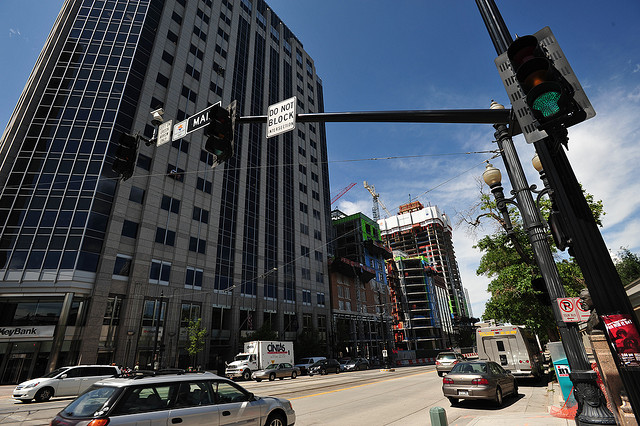<image>What do the hand sign and the red light in the picture have in common? It is unknown what the hand sign and red light in the picture have in common. What do the hand sign and the red light in the picture have in common? I don't know what the hand sign and the red light in the picture have in common. It can be their shape, color or they can be on the same pole. 